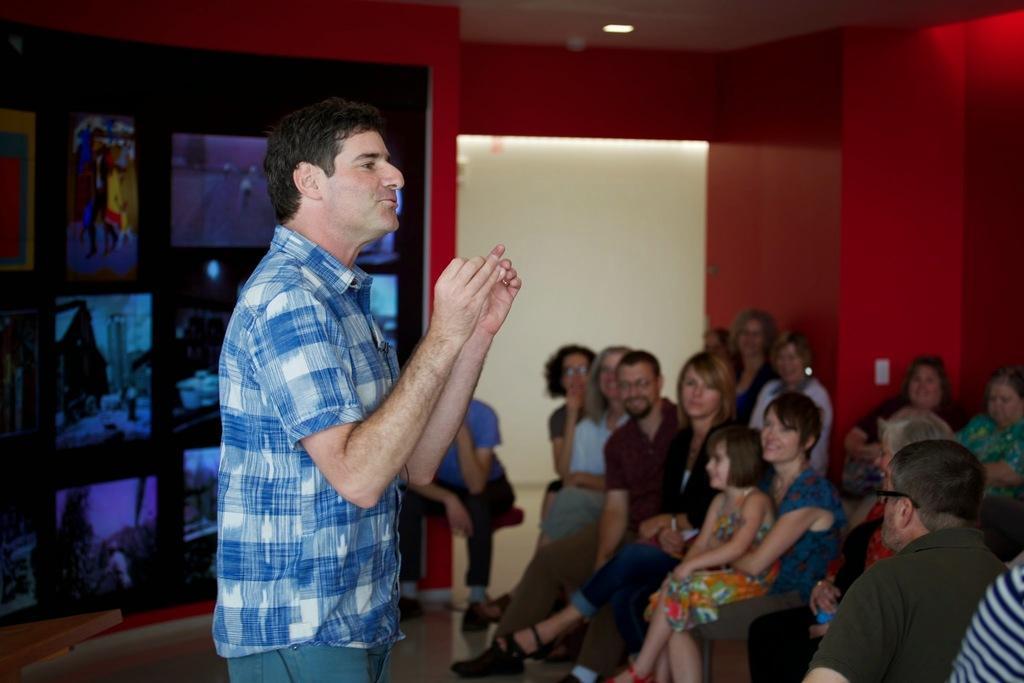How would you summarize this image in a sentence or two? In this image, we can see people wearing clothes. There are screens on the left side of the image. There is a light at the top of the image. There is a photo in the top left of the image. 